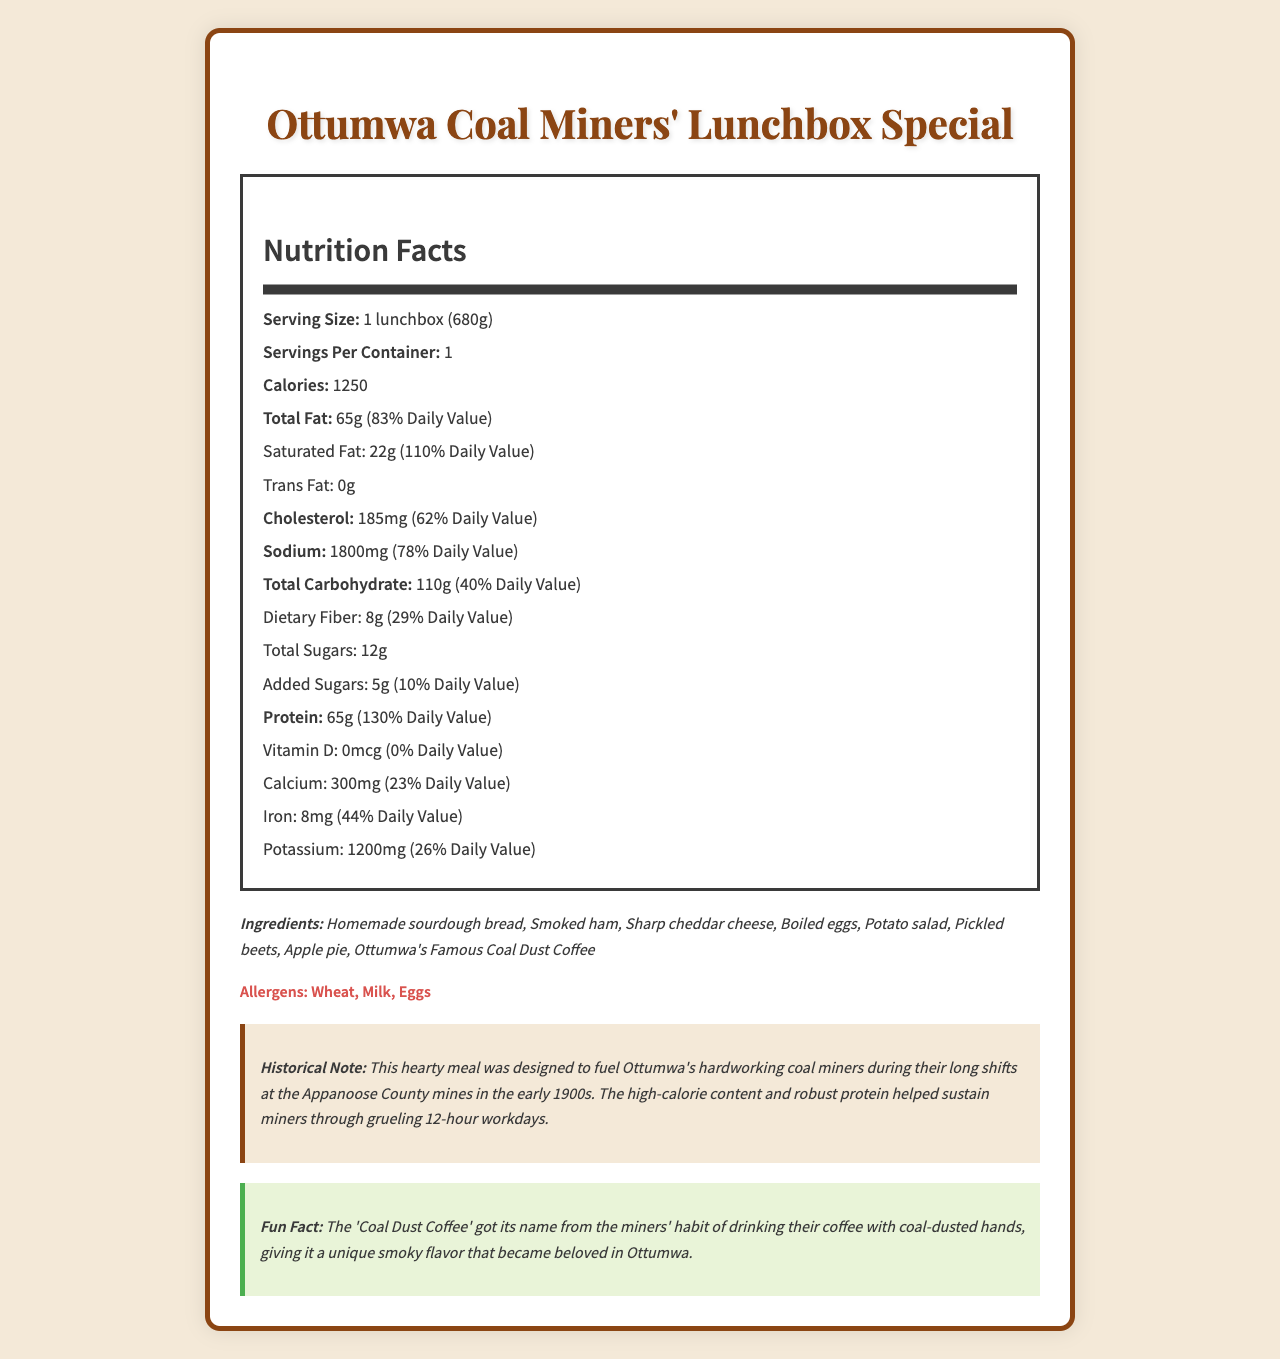What is the serving size of the Ottumwa Coal Miners' Lunchbox Special? The serving size is clearly listed as "1 lunchbox (680g)" in the nutrition label.
Answer: 1 lunchbox (680g) How many calories are in a serving of Ottumwa Coal Miners' Lunchbox Special? The calories per serving are prominently displayed as 1250.
Answer: 1250 What is the total fat content in grams and its daily value percentage? The total fat is 65g and the daily value percentage is 83%.
Answer: 65g, 83% What is the daily value percentage of cholesterol in this meal? The cholesterol daily value percentage is shown as 62%.
Answer: 62% What are the three top allergens mentioned in this meal? The allergens section lists Wheat, Milk, and Eggs.
Answer: Wheat, Milk, Eggs How much protein does one serving of the lunchbox provide? A. 45g B. 55g C. 65g D. 75g The nutrition label clearly states that the protein content is 65g.
Answer: C. 65g Which ingredient is NOT part of the Ottumwa Coal Miners' Lunchbox Special? 1. Smoked ham 2. Potato salad 3. Grilled chicken 4. Apple pie Grilled chicken is not listed among the ingredients; the lunchbox contains Smoked ham, Potato salad, and Apple pie among other items.
Answer: 3. Grilled chicken Does the Ottumwa Coal Miners' Lunchbox Special contain any trans fat? The label shows "Trans Fat: 0g," indicating there is no trans fat in the meal.
Answer: No Summarize the document. The document is a nutrition facts label for the Ottumwa Coal Miners' Lunchbox Special, detailing serving size, calories, macronutrients, vitamins, and minerals. It also lists ingredients, allergens, and includes a historical note and an interesting fun fact.
Answer: The document provides detailed nutritional information about the Ottumwa Coal Miners' Lunchbox Special, including its high protein and calorie content designed to sustain coal miners. It outlines ingredients, allergens, and provides historical context, noting the meal's historical significance and a fun fact about its unique coffee. Why was the Ottumwa Coal Miners' Lunchbox Special high in calories and protein? The historical note explains that the high-calorie and protein content was designed to sustain miners through 12-hour workdays.
Answer: To fuel hardworking coal miners during their long shifts. What unique ingredient gives the coffee its distinctive flavor? The fun fact mentions that the 'Coal Dust Coffee' gets its unique smoky flavor from coal dust on the miners' hands.
Answer: Coal dust How much calcium is in the lunchbox special and its daily value percentage? The nutrition label lists calcium content as 300mg and its daily value percentage as 23%.
Answer: 300mg, 23% How many grams of dietary fiber are in one serving? The label specifically states that there are 8 grams of dietary fiber.
Answer: 8g Can you find out the number of calories from fat? The document provides the total fat content and calories but does not specify the exact number of calories from fat.
Answer: Not enough information What is the total carbohydrate content and its daily value percentage? The total carbohydrate content is listed as 110g with a daily value percentage of 40%.
Answer: 110g, 40% What percentage of the daily value for sodium does the lunchbox provide? The sodium content is 1800mg with a daily value percentage of 78%.
Answer: 78% What historical period is associated with the meal? The historical note specifies that this meal was designed for coal miners in the early 1900s.
Answer: Early 1900s Is there any vitamin D in this meal? True or False The label shows that the Vitamin D content is 0mcg, indicating there is no vitamin D in the meal.
Answer: False 